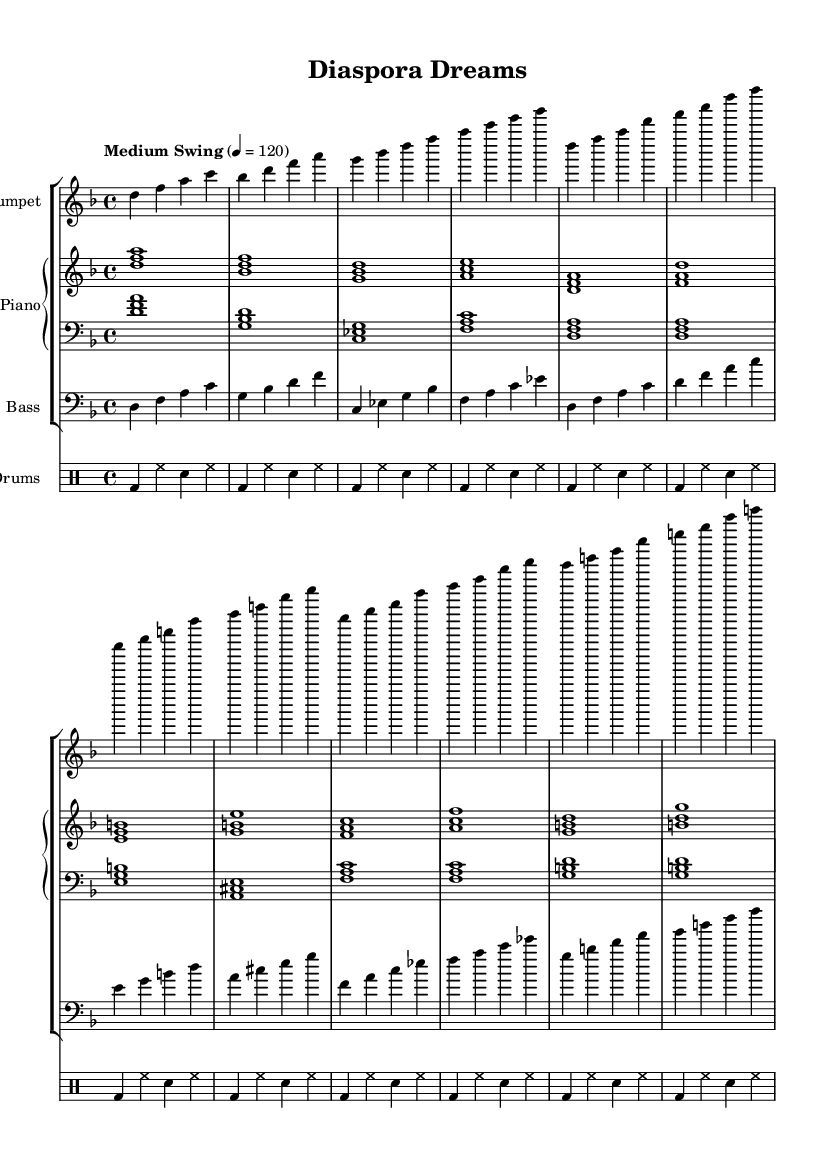What is the key signature of this music? The key signature is indicated at the beginning of the staff, which shows two flats (B flat and E flat). Hence, the key is D minor.
Answer: D minor What is the time signature of this music? The time signature appears after the key signature, indicating that there are four beats per measure (4/4).
Answer: 4/4 What is the tempo marking for this piece? The tempo marking is noted above the music, indicating a "Medium Swing" tempo at 120 beats per minute.
Answer: Medium Swing How many measures are in the main sections (A and B) of the piece? The A section has 8 measures and the B section also has 8 measures, making a total of 16 measures for the main sections.
Answer: 16 measures What is the rhythmic pattern used in the drum part? The drum part utilizes a basic swing pattern, typically using a bass drum on beats 1 and 3 and a snare drum on 2 and 4, which is standard in jazz music.
Answer: Basic swing pattern Which instrument plays the lead melody in the intro section? The lead melody is played by the trumpet, as it is the first instrument listed and the part starts with the notes in the intro section.
Answer: Trumpet How does the bass line contribute to the "walking" feel characteristic of jazz? The bass line features quarter notes that move through the chord changes smoothly, creating a "walking" feel typical of jazz bass lines, maintaining a consistent groove.
Answer: Walking feel 